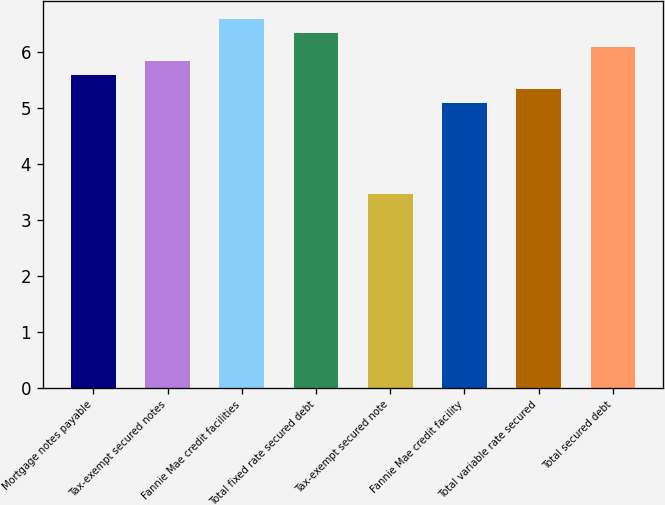<chart> <loc_0><loc_0><loc_500><loc_500><bar_chart><fcel>Mortgage notes payable<fcel>Tax-exempt secured notes<fcel>Fannie Mae credit facilities<fcel>Total fixed rate secured debt<fcel>Tax-exempt secured note<fcel>Fannie Mae credit facility<fcel>Total variable rate secured<fcel>Total secured debt<nl><fcel>5.58<fcel>5.83<fcel>6.58<fcel>6.33<fcel>3.47<fcel>5.08<fcel>5.33<fcel>6.08<nl></chart> 